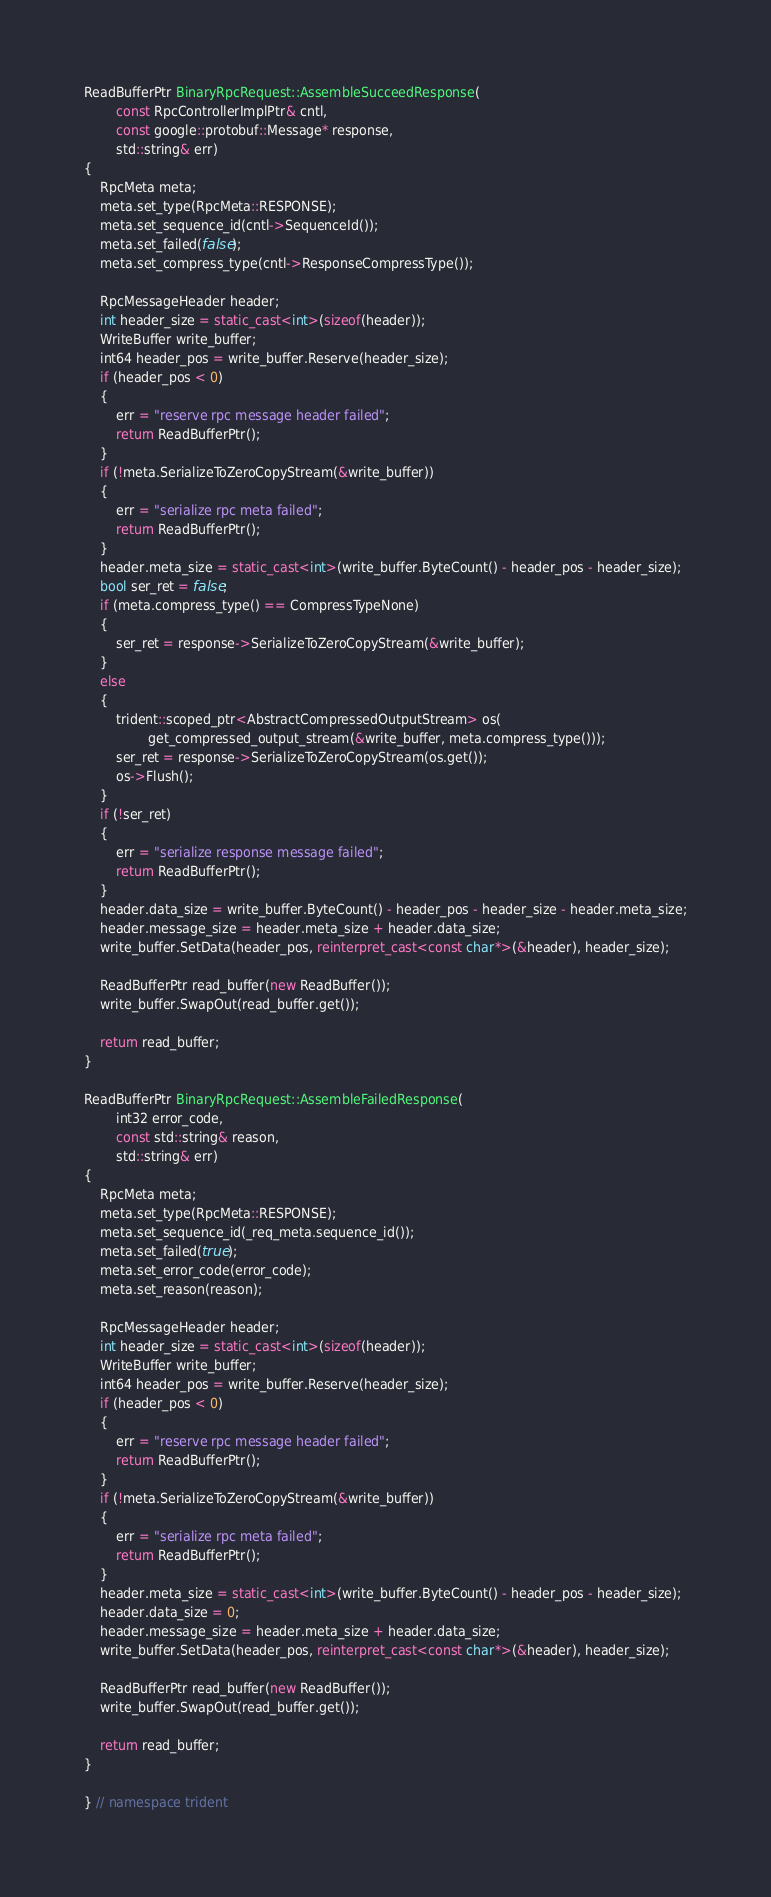<code> <loc_0><loc_0><loc_500><loc_500><_C++_>ReadBufferPtr BinaryRpcRequest::AssembleSucceedResponse(
        const RpcControllerImplPtr& cntl,
        const google::protobuf::Message* response,
        std::string& err)
{
    RpcMeta meta;
    meta.set_type(RpcMeta::RESPONSE);
    meta.set_sequence_id(cntl->SequenceId());
    meta.set_failed(false);
    meta.set_compress_type(cntl->ResponseCompressType());

    RpcMessageHeader header;
    int header_size = static_cast<int>(sizeof(header));
    WriteBuffer write_buffer;
    int64 header_pos = write_buffer.Reserve(header_size);
    if (header_pos < 0)
    {
        err = "reserve rpc message header failed";
        return ReadBufferPtr();
    }
    if (!meta.SerializeToZeroCopyStream(&write_buffer))
    {
        err = "serialize rpc meta failed";
        return ReadBufferPtr();
    }
    header.meta_size = static_cast<int>(write_buffer.ByteCount() - header_pos - header_size);
    bool ser_ret = false;
    if (meta.compress_type() == CompressTypeNone)
    {
        ser_ret = response->SerializeToZeroCopyStream(&write_buffer);
    }
    else
    {
        trident::scoped_ptr<AbstractCompressedOutputStream> os(
                get_compressed_output_stream(&write_buffer, meta.compress_type()));
        ser_ret = response->SerializeToZeroCopyStream(os.get());
        os->Flush();
    }
    if (!ser_ret)
    {
        err = "serialize response message failed";
        return ReadBufferPtr();
    }
    header.data_size = write_buffer.ByteCount() - header_pos - header_size - header.meta_size;
    header.message_size = header.meta_size + header.data_size;
    write_buffer.SetData(header_pos, reinterpret_cast<const char*>(&header), header_size);

    ReadBufferPtr read_buffer(new ReadBuffer());
    write_buffer.SwapOut(read_buffer.get());

    return read_buffer;
}

ReadBufferPtr BinaryRpcRequest::AssembleFailedResponse(
        int32 error_code,
        const std::string& reason,
        std::string& err)
{
    RpcMeta meta;
    meta.set_type(RpcMeta::RESPONSE);
    meta.set_sequence_id(_req_meta.sequence_id());
    meta.set_failed(true);
    meta.set_error_code(error_code);
    meta.set_reason(reason);

    RpcMessageHeader header;
    int header_size = static_cast<int>(sizeof(header));
    WriteBuffer write_buffer;
    int64 header_pos = write_buffer.Reserve(header_size);
    if (header_pos < 0)
    {
        err = "reserve rpc message header failed";
        return ReadBufferPtr();
    }
    if (!meta.SerializeToZeroCopyStream(&write_buffer))
    {
        err = "serialize rpc meta failed";
        return ReadBufferPtr();
    }
    header.meta_size = static_cast<int>(write_buffer.ByteCount() - header_pos - header_size);
    header.data_size = 0;
    header.message_size = header.meta_size + header.data_size;
    write_buffer.SetData(header_pos, reinterpret_cast<const char*>(&header), header_size);

    ReadBufferPtr read_buffer(new ReadBuffer());
    write_buffer.SwapOut(read_buffer.get());

    return read_buffer;
}

} // namespace trident

</code> 